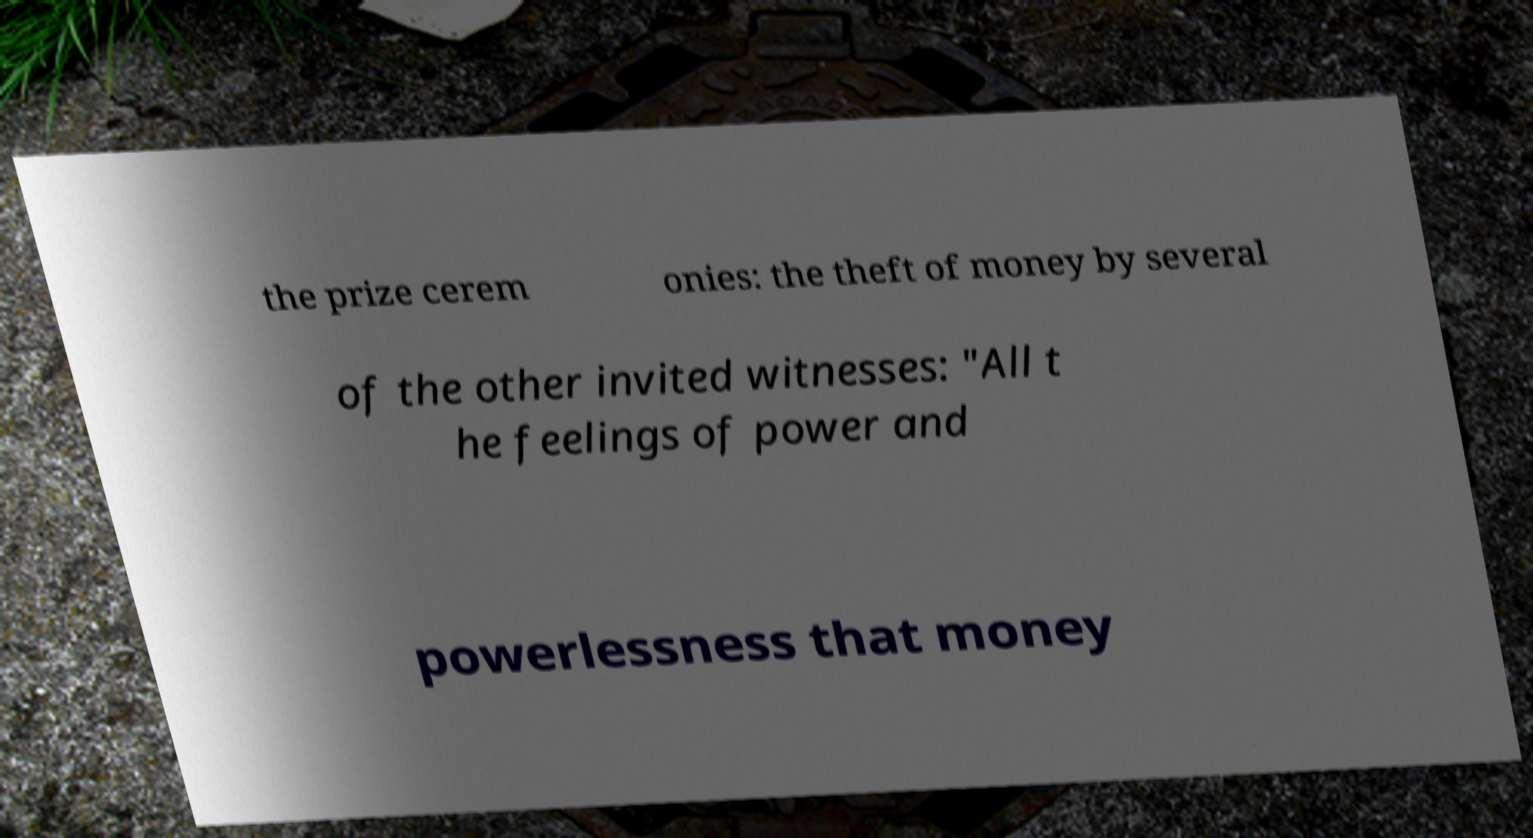Please identify and transcribe the text found in this image. the prize cerem onies: the theft of money by several of the other invited witnesses: "All t he feelings of power and powerlessness that money 